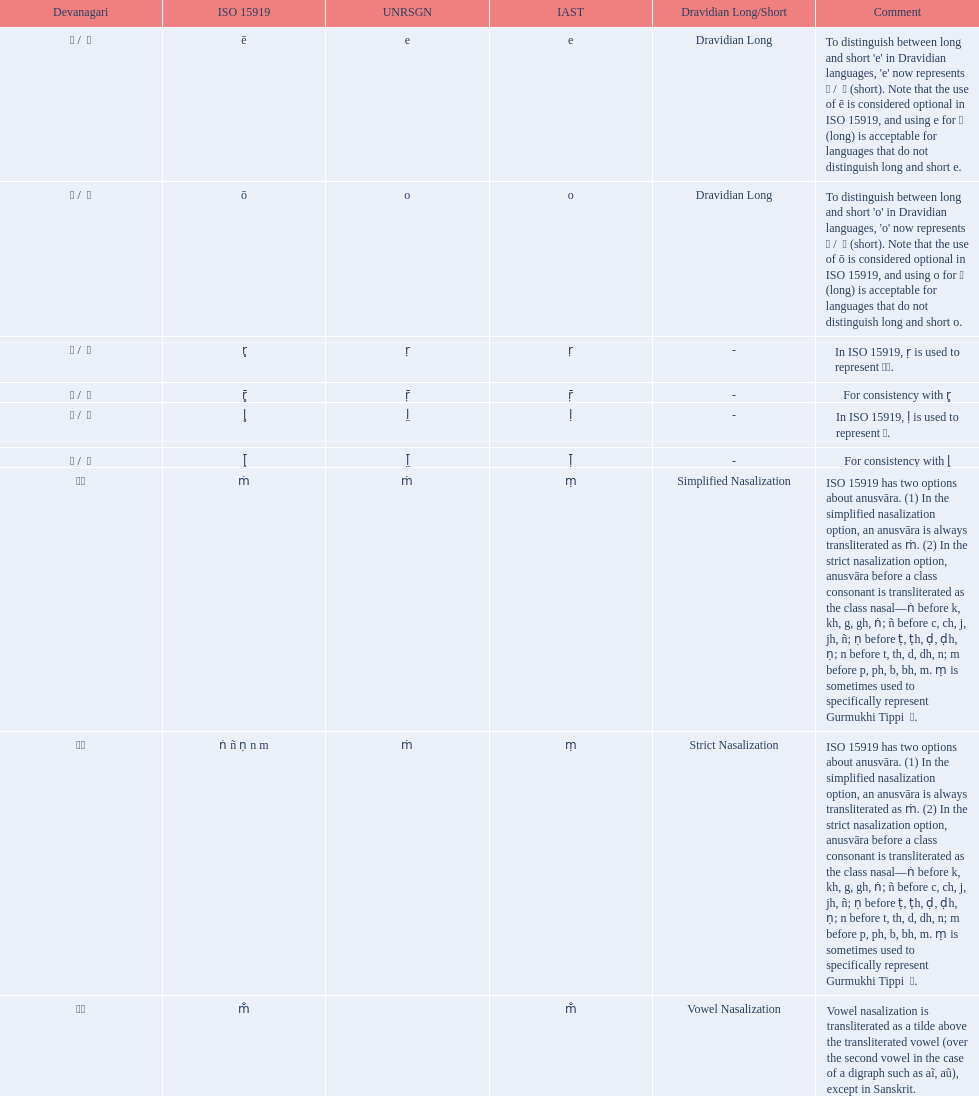What iast is listed before the o? E. 